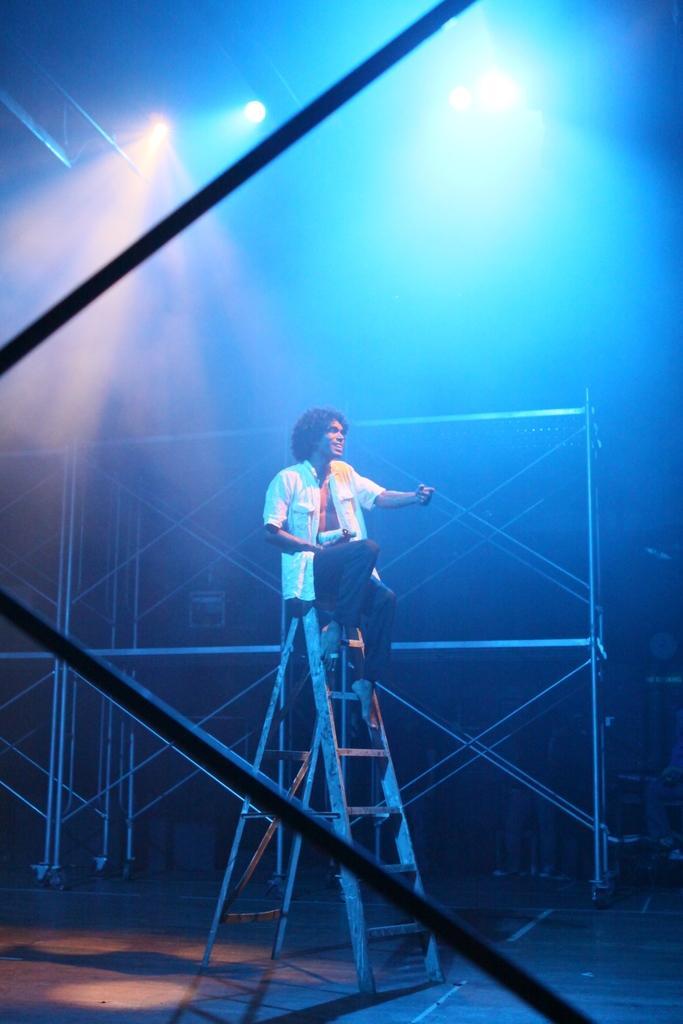Can you describe this image briefly? In this image I can see a person sitting on the ladder and the person is wearing white shirt, black pant and holding some object. Background I can see few poles and lights. 